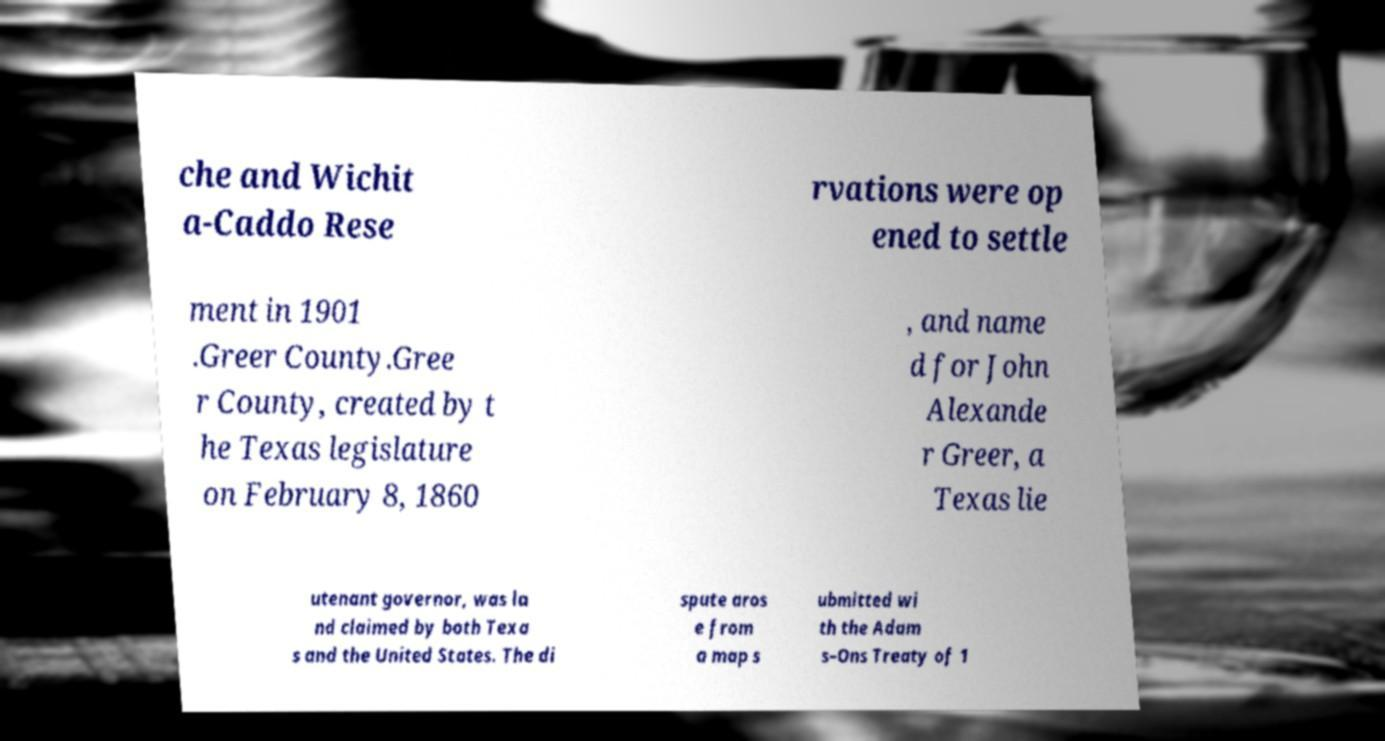Could you extract and type out the text from this image? che and Wichit a-Caddo Rese rvations were op ened to settle ment in 1901 .Greer County.Gree r County, created by t he Texas legislature on February 8, 1860 , and name d for John Alexande r Greer, a Texas lie utenant governor, was la nd claimed by both Texa s and the United States. The di spute aros e from a map s ubmitted wi th the Adam s–Ons Treaty of 1 